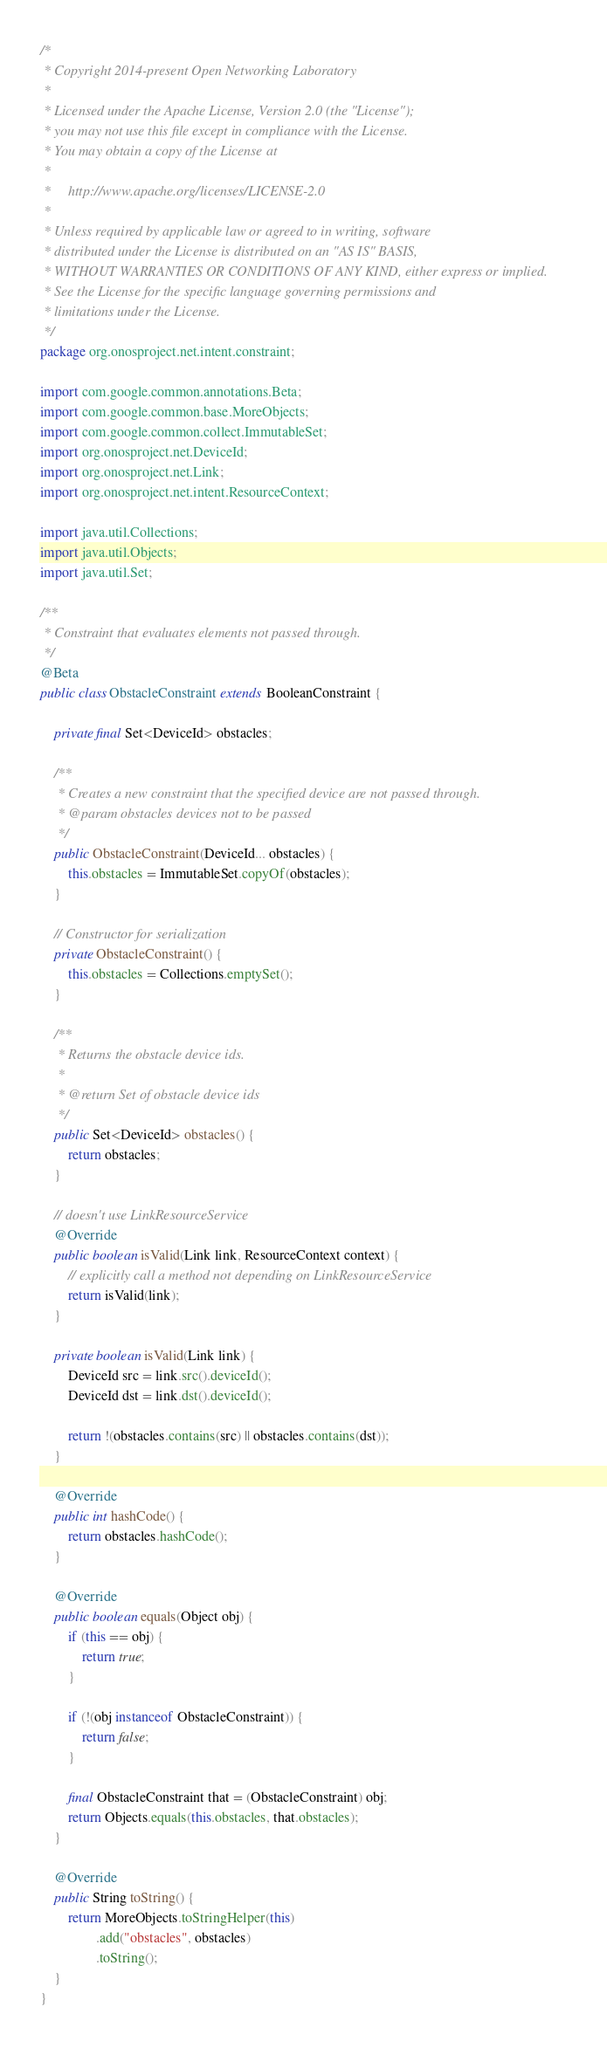<code> <loc_0><loc_0><loc_500><loc_500><_Java_>/*
 * Copyright 2014-present Open Networking Laboratory
 *
 * Licensed under the Apache License, Version 2.0 (the "License");
 * you may not use this file except in compliance with the License.
 * You may obtain a copy of the License at
 *
 *     http://www.apache.org/licenses/LICENSE-2.0
 *
 * Unless required by applicable law or agreed to in writing, software
 * distributed under the License is distributed on an "AS IS" BASIS,
 * WITHOUT WARRANTIES OR CONDITIONS OF ANY KIND, either express or implied.
 * See the License for the specific language governing permissions and
 * limitations under the License.
 */
package org.onosproject.net.intent.constraint;

import com.google.common.annotations.Beta;
import com.google.common.base.MoreObjects;
import com.google.common.collect.ImmutableSet;
import org.onosproject.net.DeviceId;
import org.onosproject.net.Link;
import org.onosproject.net.intent.ResourceContext;

import java.util.Collections;
import java.util.Objects;
import java.util.Set;

/**
 * Constraint that evaluates elements not passed through.
 */
@Beta
public class ObstacleConstraint extends BooleanConstraint {

    private final Set<DeviceId> obstacles;

    /**
     * Creates a new constraint that the specified device are not passed through.
     * @param obstacles devices not to be passed
     */
    public ObstacleConstraint(DeviceId... obstacles) {
        this.obstacles = ImmutableSet.copyOf(obstacles);
    }

    // Constructor for serialization
    private ObstacleConstraint() {
        this.obstacles = Collections.emptySet();
    }

    /**
     * Returns the obstacle device ids.
     *
     * @return Set of obstacle device ids
     */
    public Set<DeviceId> obstacles() {
        return obstacles;
    }

    // doesn't use LinkResourceService
    @Override
    public boolean isValid(Link link, ResourceContext context) {
        // explicitly call a method not depending on LinkResourceService
        return isValid(link);
    }

    private boolean isValid(Link link) {
        DeviceId src = link.src().deviceId();
        DeviceId dst = link.dst().deviceId();

        return !(obstacles.contains(src) || obstacles.contains(dst));
    }

    @Override
    public int hashCode() {
        return obstacles.hashCode();
    }

    @Override
    public boolean equals(Object obj) {
        if (this == obj) {
            return true;
        }

        if (!(obj instanceof ObstacleConstraint)) {
            return false;
        }

        final ObstacleConstraint that = (ObstacleConstraint) obj;
        return Objects.equals(this.obstacles, that.obstacles);
    }

    @Override
    public String toString() {
        return MoreObjects.toStringHelper(this)
                .add("obstacles", obstacles)
                .toString();
    }
}
</code> 